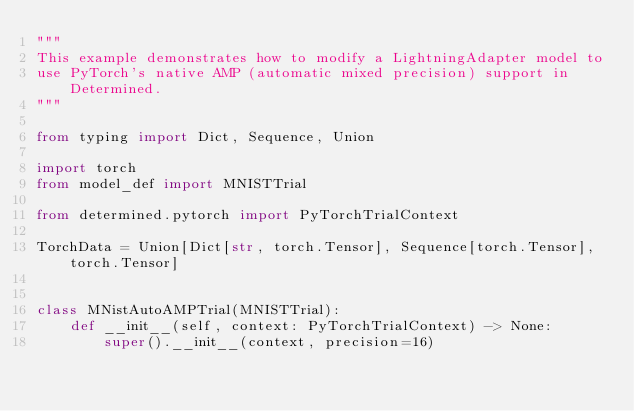<code> <loc_0><loc_0><loc_500><loc_500><_Python_>"""
This example demonstrates how to modify a LightningAdapter model to
use PyTorch's native AMP (automatic mixed precision) support in Determined.
"""

from typing import Dict, Sequence, Union

import torch
from model_def import MNISTTrial

from determined.pytorch import PyTorchTrialContext

TorchData = Union[Dict[str, torch.Tensor], Sequence[torch.Tensor], torch.Tensor]


class MNistAutoAMPTrial(MNISTTrial):
    def __init__(self, context: PyTorchTrialContext) -> None:
        super().__init__(context, precision=16)
</code> 